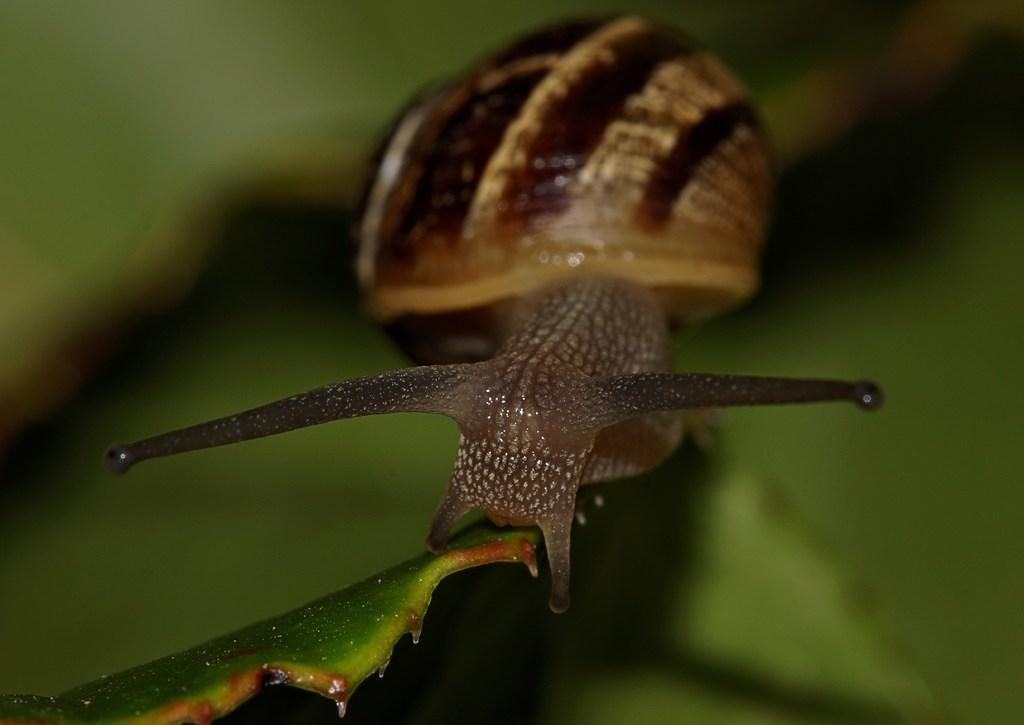What is the main subject of the image? There is a snail in the image. Where is the snail located? The snail is on a green leaf. What can be observed about the background of the image? The background of the image is green and blurred. What type of cough medicine is the snail holding in the image? There is no cough medicine present in the image; it features a snail on a green leaf with a blurred background. 